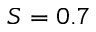Convert formula to latex. <formula><loc_0><loc_0><loc_500><loc_500>S = 0 . 7</formula> 